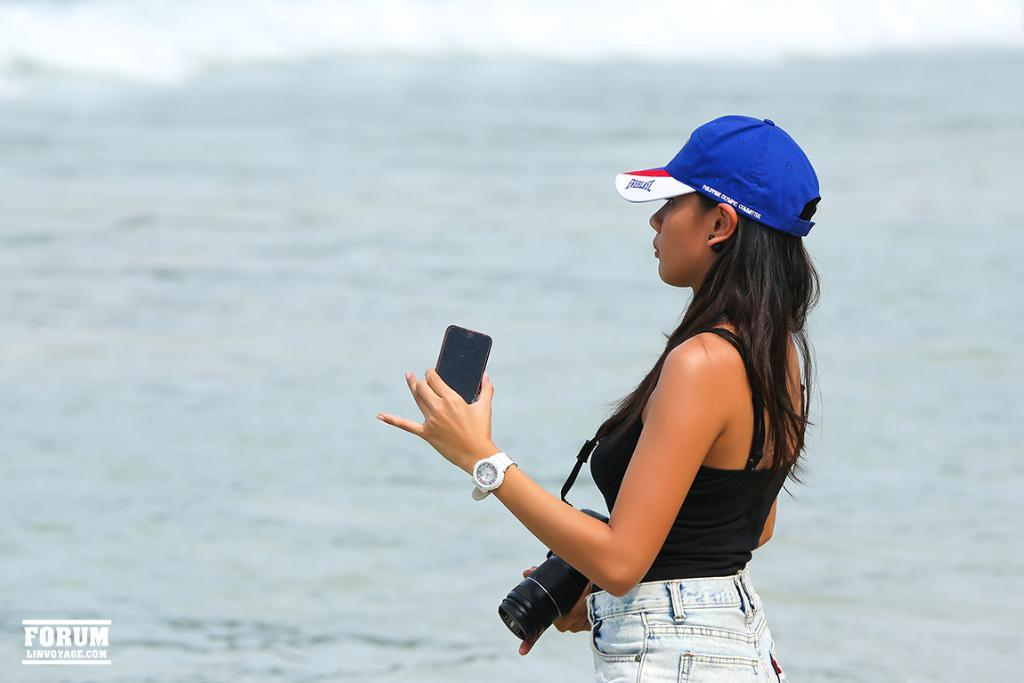Who is the main subject in the image? There is a girl in the image. What is the girl wearing on her head? The girl is wearing a cap. What accessory is the girl wearing on her wrist? The girl is wearing a watch. What is the girl holding in her hands? The girl is holding a camera and a mobile. What type of stamp can be seen on the girl's forehead in the image? There is no stamp present on the girl's forehead in the image. What memory does the girl have of her childhood in the image? The image does not provide any information about the girl's memories or childhood. 